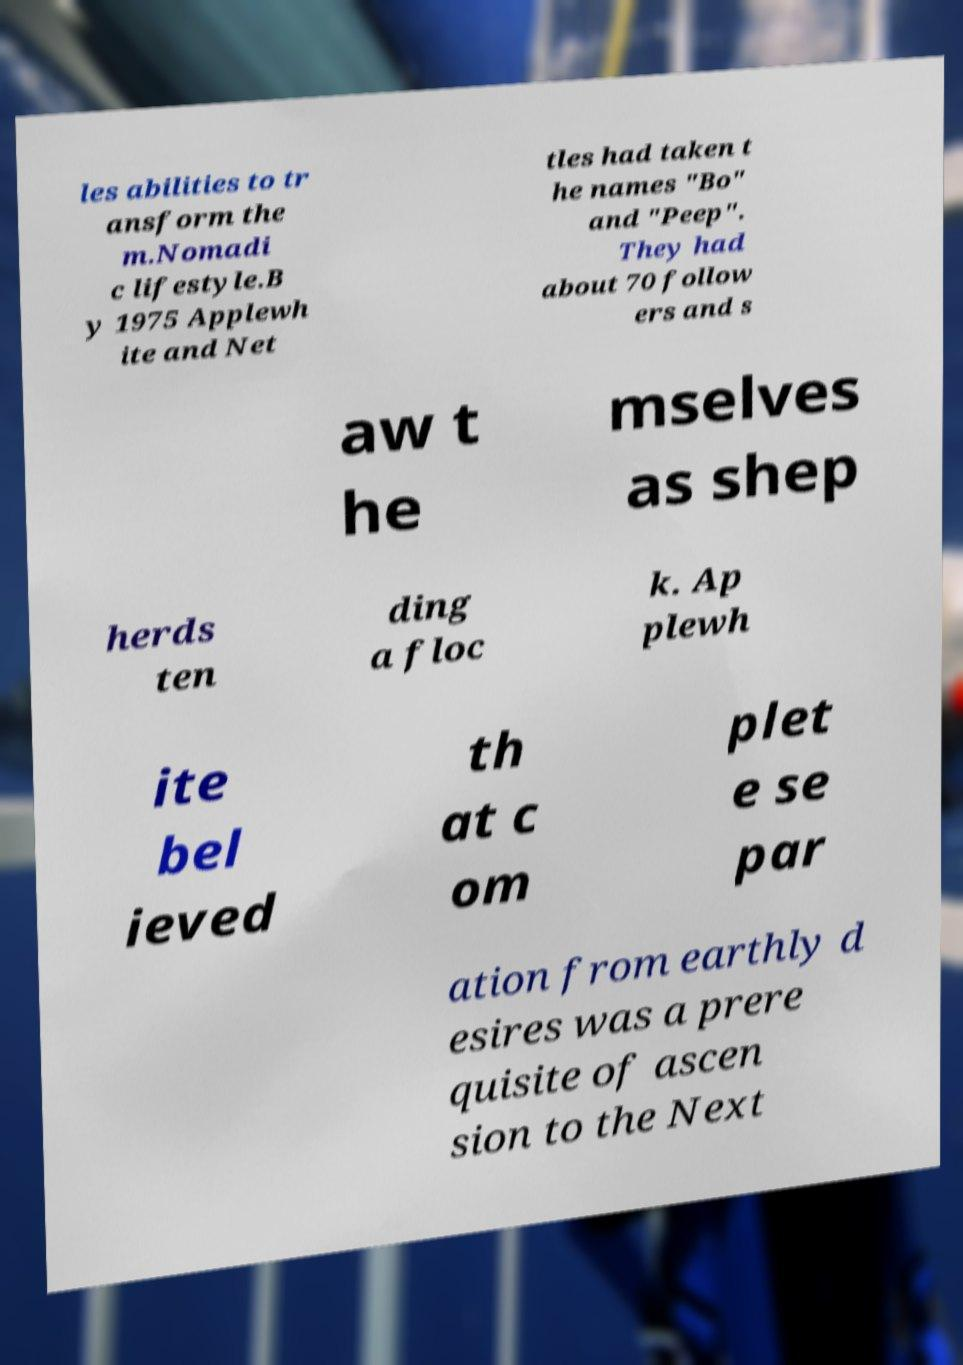Can you accurately transcribe the text from the provided image for me? les abilities to tr ansform the m.Nomadi c lifestyle.B y 1975 Applewh ite and Net tles had taken t he names "Bo" and "Peep". They had about 70 follow ers and s aw t he mselves as shep herds ten ding a floc k. Ap plewh ite bel ieved th at c om plet e se par ation from earthly d esires was a prere quisite of ascen sion to the Next 